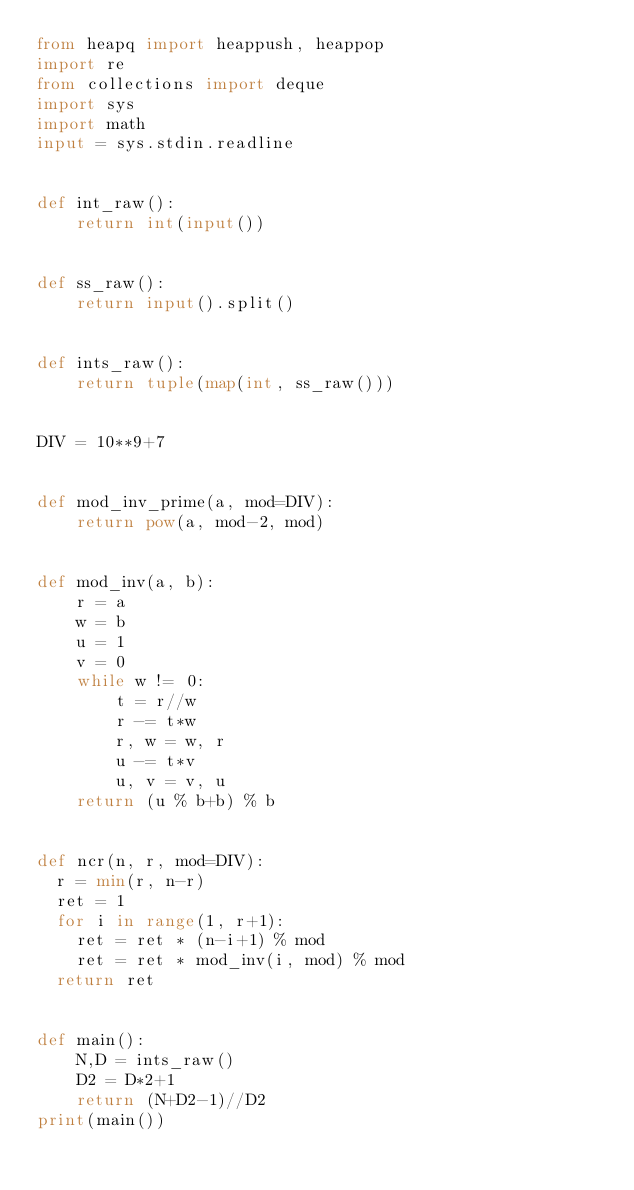Convert code to text. <code><loc_0><loc_0><loc_500><loc_500><_Python_>from heapq import heappush, heappop
import re
from collections import deque
import sys
import math
input = sys.stdin.readline


def int_raw():
    return int(input())


def ss_raw():
    return input().split()


def ints_raw():
    return tuple(map(int, ss_raw()))


DIV = 10**9+7


def mod_inv_prime(a, mod=DIV):
    return pow(a, mod-2, mod)


def mod_inv(a, b):
    r = a
    w = b
    u = 1
    v = 0
    while w != 0:
        t = r//w
        r -= t*w
        r, w = w, r
        u -= t*v
        u, v = v, u
    return (u % b+b) % b


def ncr(n, r, mod=DIV):
	r = min(r, n-r)
	ret = 1
	for i in range(1, r+1):
		ret = ret * (n-i+1) % mod
		ret = ret * mod_inv(i, mod) % mod
	return ret


def main():
    N,D = ints_raw()
    D2 = D*2+1
    return (N+D2-1)//D2
print(main())
</code> 